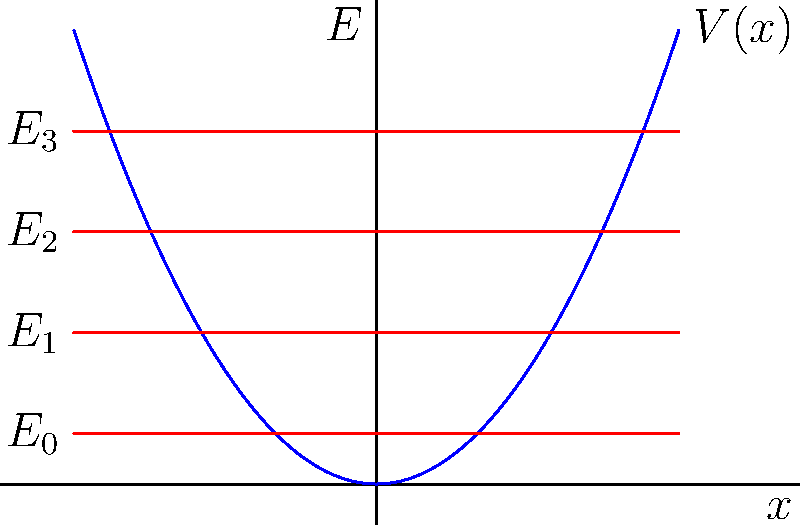In the quantum harmonic oscillator model shown above, what is the energy difference between any two adjacent energy levels? To determine the energy difference between adjacent energy levels in a quantum harmonic oscillator, we can follow these steps:

1. Recall the energy eigenvalues for a quantum harmonic oscillator:
   $$E_n = \hbar \omega (n + \frac{1}{2})$$
   where $n = 0, 1, 2, ...$, $\hbar$ is the reduced Planck's constant, and $\omega$ is the angular frequency of the oscillator.

2. Observe the energy levels in the diagram:
   $E_0 = 0.5\hbar\omega$
   $E_1 = 1.5\hbar\omega$
   $E_2 = 2.5\hbar\omega$
   $E_3 = 3.5\hbar\omega$

3. Calculate the difference between any two adjacent energy levels:
   $E_1 - E_0 = (1.5\hbar\omega) - (0.5\hbar\omega) = \hbar\omega$
   $E_2 - E_1 = (2.5\hbar\omega) - (1.5\hbar\omega) = \hbar\omega$
   $E_3 - E_2 = (3.5\hbar\omega) - (2.5\hbar\omega) = \hbar\omega$

4. We can generalize this for any two adjacent levels $n$ and $n+1$:
   $$E_{n+1} - E_n = [\hbar\omega(n+1+\frac{1}{2})] - [\hbar\omega(n+\frac{1}{2})] = \hbar\omega$$

Therefore, the energy difference between any two adjacent energy levels in a quantum harmonic oscillator is constant and equal to $\hbar\omega$.
Answer: $\hbar\omega$ 